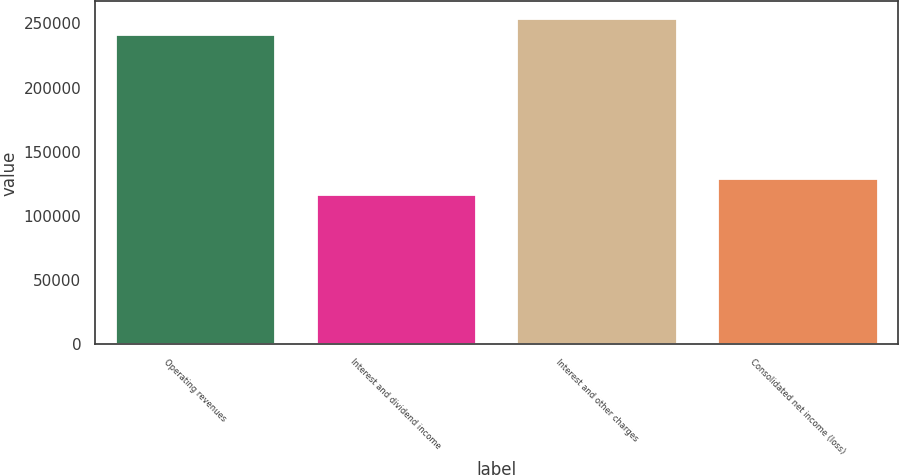Convert chart to OTSL. <chart><loc_0><loc_0><loc_500><loc_500><bar_chart><fcel>Operating revenues<fcel>Interest and dividend income<fcel>Interest and other charges<fcel>Consolidated net income (loss)<nl><fcel>241715<fcel>116830<fcel>254406<fcel>129522<nl></chart> 